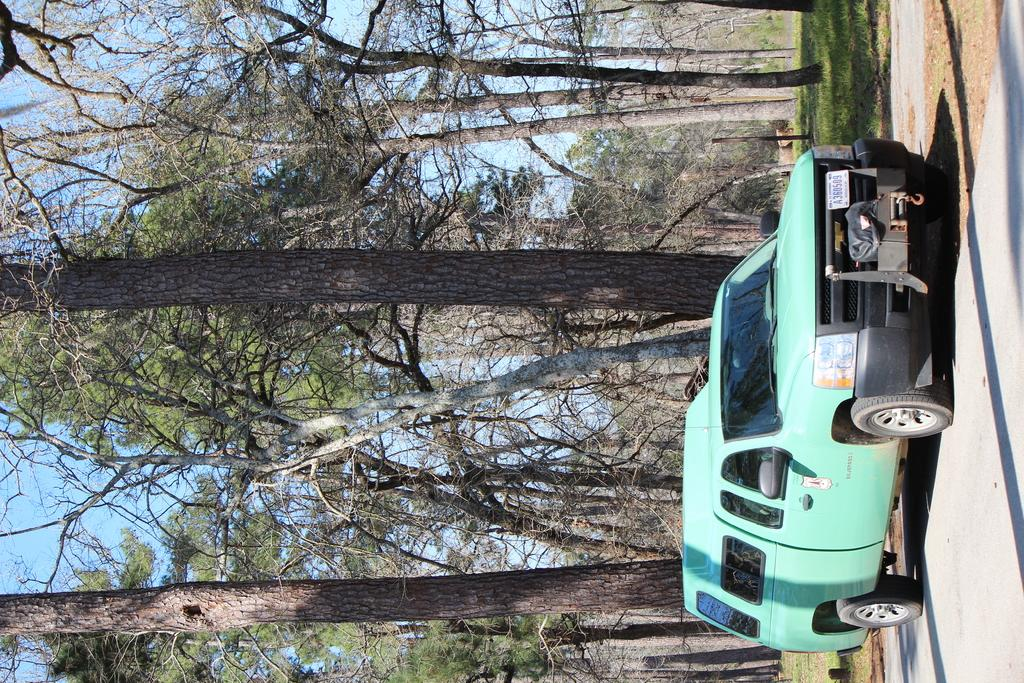What type of vehicle can be seen on the road in the image? There is a motor vehicle on the road in the image. What natural elements are visible in the image? Trees, the ground, and the sky are visible in the image. How is the vehicle being used to show the operation of a new technology in the image? The image does not depict any new technology or its operation; it simply shows a motor vehicle on the road. 